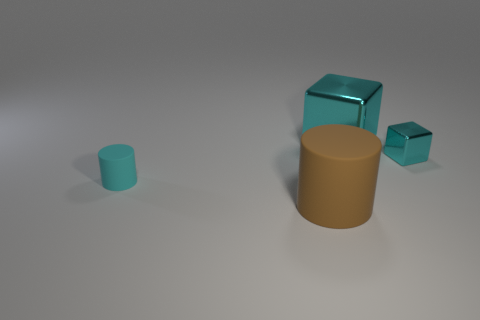There is another shiny cube that is the same color as the small cube; what is its size?
Offer a very short reply. Large. What is the shape of the tiny object that is on the right side of the rubber cylinder behind the brown matte cylinder?
Your answer should be very brief. Cube. Are there any metallic things that are to the right of the cube that is to the left of the small object that is right of the small cyan rubber cylinder?
Offer a terse response. Yes. There is a cube that is the same size as the brown object; what is its color?
Provide a succinct answer. Cyan. What is the shape of the cyan thing that is left of the tiny block and to the right of the small cyan cylinder?
Make the answer very short. Cube. There is a cyan cube on the right side of the big object that is to the right of the big matte object; what size is it?
Your response must be concise. Small. How many other shiny objects have the same color as the tiny metal thing?
Provide a succinct answer. 1. What number of other objects are there of the same size as the brown matte object?
Keep it short and to the point. 1. There is a thing that is in front of the big metal object and to the right of the big brown rubber cylinder; what is its size?
Your answer should be compact. Small. What number of other metallic objects have the same shape as the large cyan shiny object?
Make the answer very short. 1. 